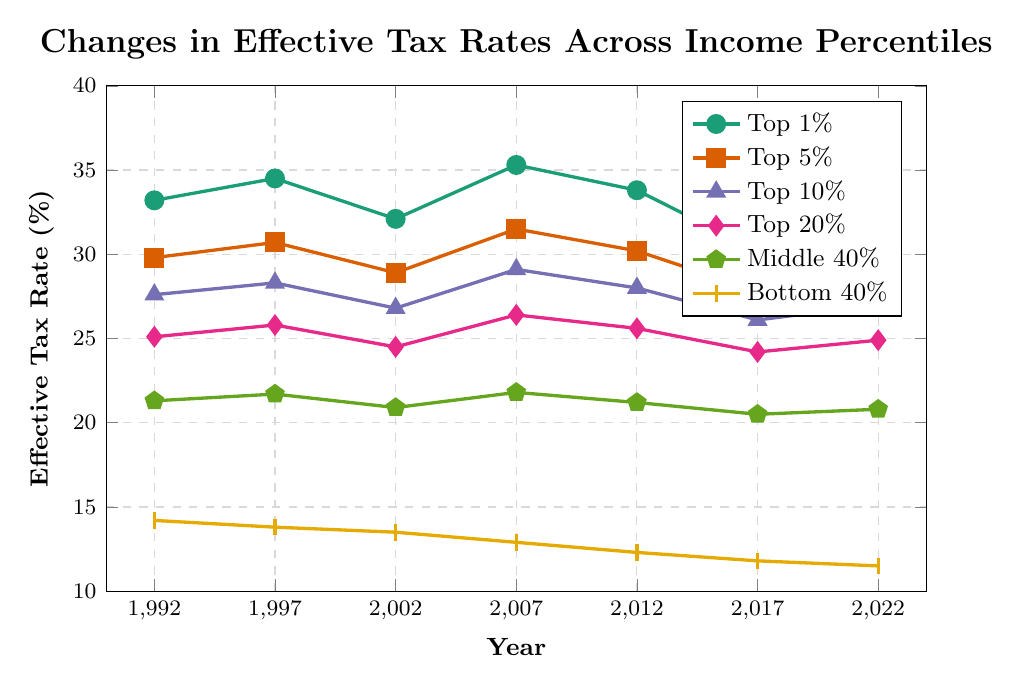What's the trend in effective tax rates for the Top 1% from 1992 to 2022? The effective tax rate for the Top 1% started at 33.2% in 1992, increased to a peak of 35.3% in 2007, and generally decreased to 31.5% by 2022.
Answer: Decreasing What income percentile had the steepest decline in effective tax rates from 1992 to 2022? The Bottom 40% had the most noticeable decline, starting at 14.2% in 1992 and ending at 11.5% in 2022.
Answer: Bottom 40% How did the effective tax rate for the Middle 40% change between 2007 and 2017? The effective tax rate for the Middle 40% decreased from 21.8% in 2007 to 20.5% in 2017.
Answer: Decreased What's the average effective tax rate for the Top 10% over all the years shown? The average is calculated by summing the effective tax rates for each year (27.6 + 28.3 + 26.8 + 29.1 + 28 + 26.1 + 27) = 193.9 and then dividing by the number of years (7). The average is 193.9 / 7 = 27.7%.
Answer: 27.7% In which year did the Bottom 40% have its highest effective tax rate? The highest effective tax rate for the Bottom 40% occurs in 1992 at 14.2%.
Answer: 1992 How does the effective tax rate of the Top 5% in 2022 compare to that of the Top 20% in the same year? The effective tax rate for the Top 5% in 2022 was 28.9%, while for the Top 20%, it was 24.9%. Thus, the Top 5% had a higher tax rate.
Answer: Top 5% had a higher tax rate What's the difference between the effective tax rates of the Top 1% and the Bottom 40% in 2017? In 2017, the effective tax rate for the Top 1% was 30.2%, and for the Bottom 40%, it was 11.8%. The difference is 30.2% - 11.8% = 18.4%.
Answer: 18.4% Between 1997 and 2002, which income percentile saw the largest drop in effective tax rates? The Top 1% declined from 34.5% to 32.1%, resulting in a decrease of 2.4%, which is the largest among all groups.
Answer: Top 1% How did the effective tax rates for the Top 20% change over the entire period shown? The effective tax rates for the Top 20% started at 25.1% in 1992, showed a small increase and decrease across the years, and ended at 24.9% in 2022.
Answer: Slightly decreased What is the overall trend in effective tax rates for all income percentiles combined from 1992 to 2022? Most income percentiles exhibit a general trend of decreasing effective tax rates, especially noticeable in the Bottom 40% and Top 1%.
Answer: Decreasing 